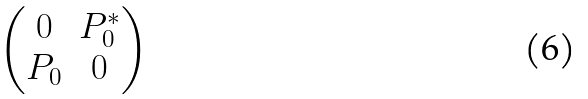<formula> <loc_0><loc_0><loc_500><loc_500>\begin{pmatrix} 0 & P _ { 0 } ^ { \ast } \\ P _ { 0 } & 0 \end{pmatrix}</formula> 